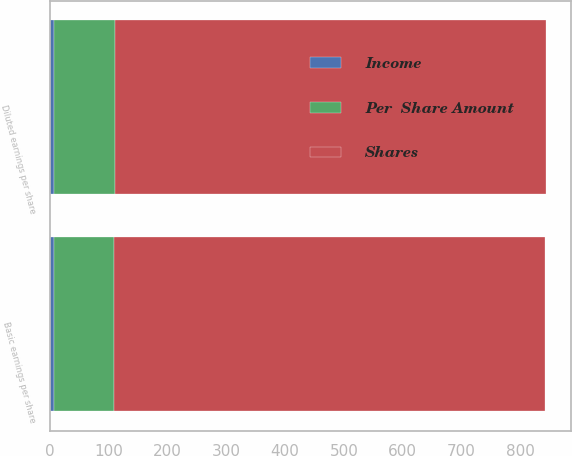Convert chart to OTSL. <chart><loc_0><loc_0><loc_500><loc_500><stacked_bar_chart><ecel><fcel>Basic earnings per share<fcel>Diluted earnings per share<nl><fcel>Shares<fcel>732.1<fcel>732.1<nl><fcel>Per  Share Amount<fcel>102.5<fcel>104.3<nl><fcel>Income<fcel>7.14<fcel>7.02<nl></chart> 